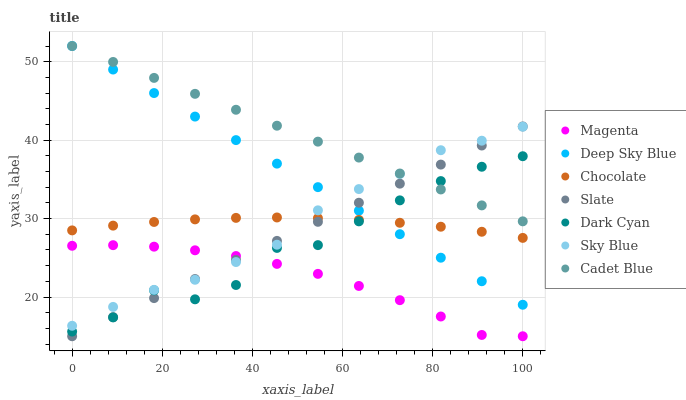Does Magenta have the minimum area under the curve?
Answer yes or no. Yes. Does Cadet Blue have the maximum area under the curve?
Answer yes or no. Yes. Does Slate have the minimum area under the curve?
Answer yes or no. No. Does Slate have the maximum area under the curve?
Answer yes or no. No. Is Cadet Blue the smoothest?
Answer yes or no. Yes. Is Dark Cyan the roughest?
Answer yes or no. Yes. Is Slate the smoothest?
Answer yes or no. No. Is Slate the roughest?
Answer yes or no. No. Does Slate have the lowest value?
Answer yes or no. Yes. Does Chocolate have the lowest value?
Answer yes or no. No. Does Deep Sky Blue have the highest value?
Answer yes or no. Yes. Does Slate have the highest value?
Answer yes or no. No. Is Chocolate less than Cadet Blue?
Answer yes or no. Yes. Is Cadet Blue greater than Chocolate?
Answer yes or no. Yes. Does Chocolate intersect Deep Sky Blue?
Answer yes or no. Yes. Is Chocolate less than Deep Sky Blue?
Answer yes or no. No. Is Chocolate greater than Deep Sky Blue?
Answer yes or no. No. Does Chocolate intersect Cadet Blue?
Answer yes or no. No. 